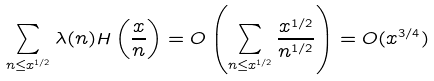<formula> <loc_0><loc_0><loc_500><loc_500>\sum _ { n \leq x ^ { 1 / 2 } } \lambda ( n ) H \left ( \frac { x } { n } \right ) = O \left ( \sum _ { n \leq x ^ { 1 / 2 } } \frac { x ^ { 1 / 2 } } { n ^ { 1 / 2 } } \right ) = O ( x ^ { 3 / 4 } )</formula> 